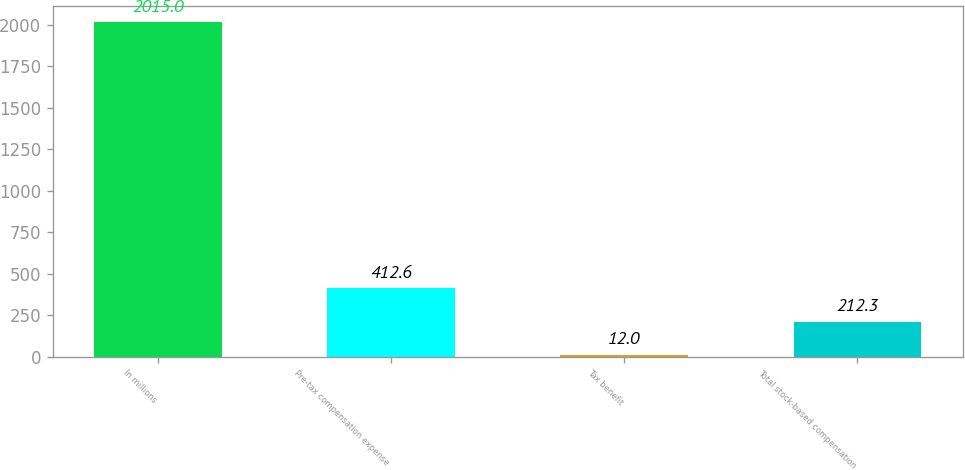Convert chart to OTSL. <chart><loc_0><loc_0><loc_500><loc_500><bar_chart><fcel>In millions<fcel>Pre-tax compensation expense<fcel>Tax benefit<fcel>Total stock-based compensation<nl><fcel>2015<fcel>412.6<fcel>12<fcel>212.3<nl></chart> 